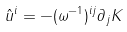Convert formula to latex. <formula><loc_0><loc_0><loc_500><loc_500>\hat { u } ^ { i } = - ( \omega ^ { - 1 } ) ^ { i j } \partial _ { j } K</formula> 